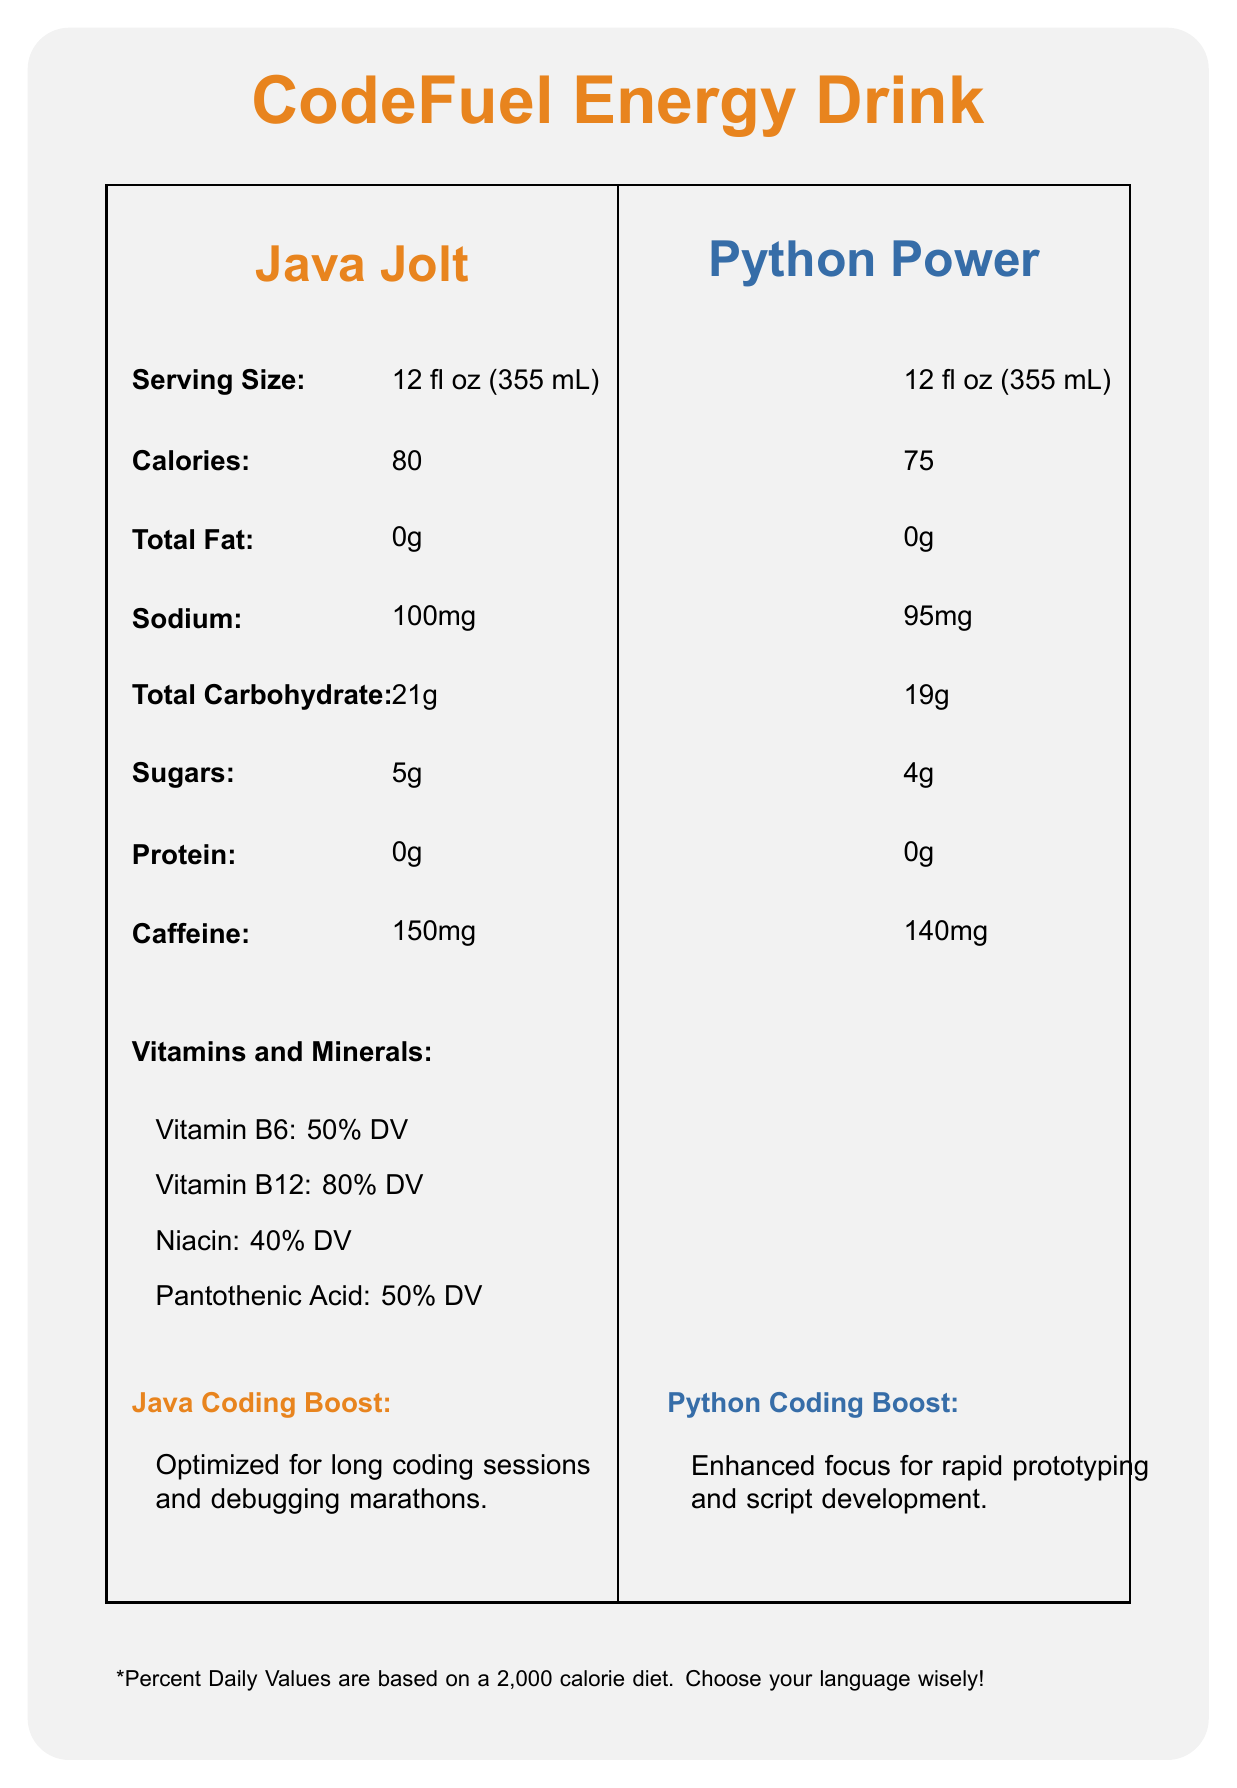what is the serving size for both flavors? The document states that the serving size for both Java Jolt and Python Power is 12 fl oz (355 mL).
Answer: 12 fl oz (355 mL) How many calories does Python Power have? The document states that Python Power contains 75 calories per serving.
Answer: 75 Which flavor has more caffeine? The document indicates that Java Jolt has 150mg of caffeine, whereas Python Power has 140mg.
Answer: Java Jolt Which flavor has less sugar? According to the document, Java Jolt has 5g of sugar, while Python Power has 4g.
Answer: Python Power What is the sodium content in Java Jolt? The sodium content in Java Jolt is listed as 100mg in the document.
Answer: 100mg How much protein is in both flavors? The document specifies that both Java Jolt and Python Power contain 0g of protein.
Answer: 0g Which flavor is best consumed while working on large-scale software projects? The recommended use for Java Jolt is best while working on large-scale software projects or enterprise applications, as per the document.
Answer: Java Jolt Which vitamin has the highest daily value percentage in both flavors? The document states that Vitamin B12 has an 80% DV in both Java Jolt and Python Power, the highest of all listed vitamins.
Answer: Vitamin B12 How many grams of total carbohydrates are in Python Power? The document lists that Python Power contains 19g of total carbohydrates.
Answer: 19g What is the difference in calorie content between the two flavors? A. 5 calories B. 10 calories C. 15 calories Java Jolt has 80 calories, and Python Power has 75 calories. The difference is 5 calories.
Answer: B. 5 calories Which flavor has more sodium? A. Java Jolt B. Python Power C. Both have equal sodium content Java Jolt has 100mg of sodium, while Python Power has 95mg, making Java Jolt the one with more sodium.
Answer: A. Java Jolt Is there any information about the manufacturing facility in the document? The document mentions that both flavors are manufactured in a facility that processes milk, soy, and tree nuts.
Answer: Yes Summarize the main differences in nutrition and recommendations between Java Jolt and Python Power. The document highlights that Java Jolt has 80 calories, 5g sugar, 150mg caffeine, and 100mg sodium, compared to Python Power's 75 calories, 4g sugar, 140mg caffeine, and 95mg sodium. Besides, the recommended uses are different: Java Jolt is for long coding sessions and large-scale projects, while Python Power is for rapid prototyping and script development.
Answer: Java Jolt contains slightly more calories, sugar, caffeine, and sodium compared to Python Power. Java Jolt is optimized for long coding sessions and enterprise projects, while Python Power enhances focus for rapid prototyping and script development. Which flavor's ingredients include Yerba Mate Extract? The document lists Yerba Mate Extract as an ingredient in Python Power, not in Java Jolt.
Answer: Python Power What is the daily value percentage of vitamins in Python Power? The daily value percentages listed in the document are the same for both flavors for these vitamins.
Answer: Vitamin B6: 50% DV, Vitamin B12: 80% DV, Niacin: 40% DV, Pantothenic Acid: 50% DV What are the benefits of Python Power compared to Java Jolt? The document states that Python Power is designed to enhance focus for rapid prototyping and script development.
Answer: Enhanced focus for rapid prototyping and script development. What is the coding fact about Java on the document? The document mentions that Java is object-oriented, platform-independent, and widely used in enterprise applications.
Answer: Java: Object-oriented, platform-independent, and widely used in enterprise applications. Which ingredient is used in Java Jolt but not in Python Power? The document lists Panax Ginseng Root Extract as an ingredient in Java Jolt; it's not listed in Python Power's ingredients.
Answer: Panax Ginseng Root Extract Describe the flavor profile of both Java Jolt and Python Power. The document describes Java Jolt's flavor as bold and robust with hints of espresso and dark chocolate, whereas Python Power is smooth and refreshing with notes of green tea and citrus.
Answer: Java Jolt has a bold and robust flavor with hints of espresso and dark chocolate, while Python Power has a smooth and refreshing flavor with notes of green tea and citrus. What is the percent daily value of Vitamin C in Python Power? The document does not provide any information about the daily value percentage of Vitamin C in Python Power.
Answer: Not enough information 